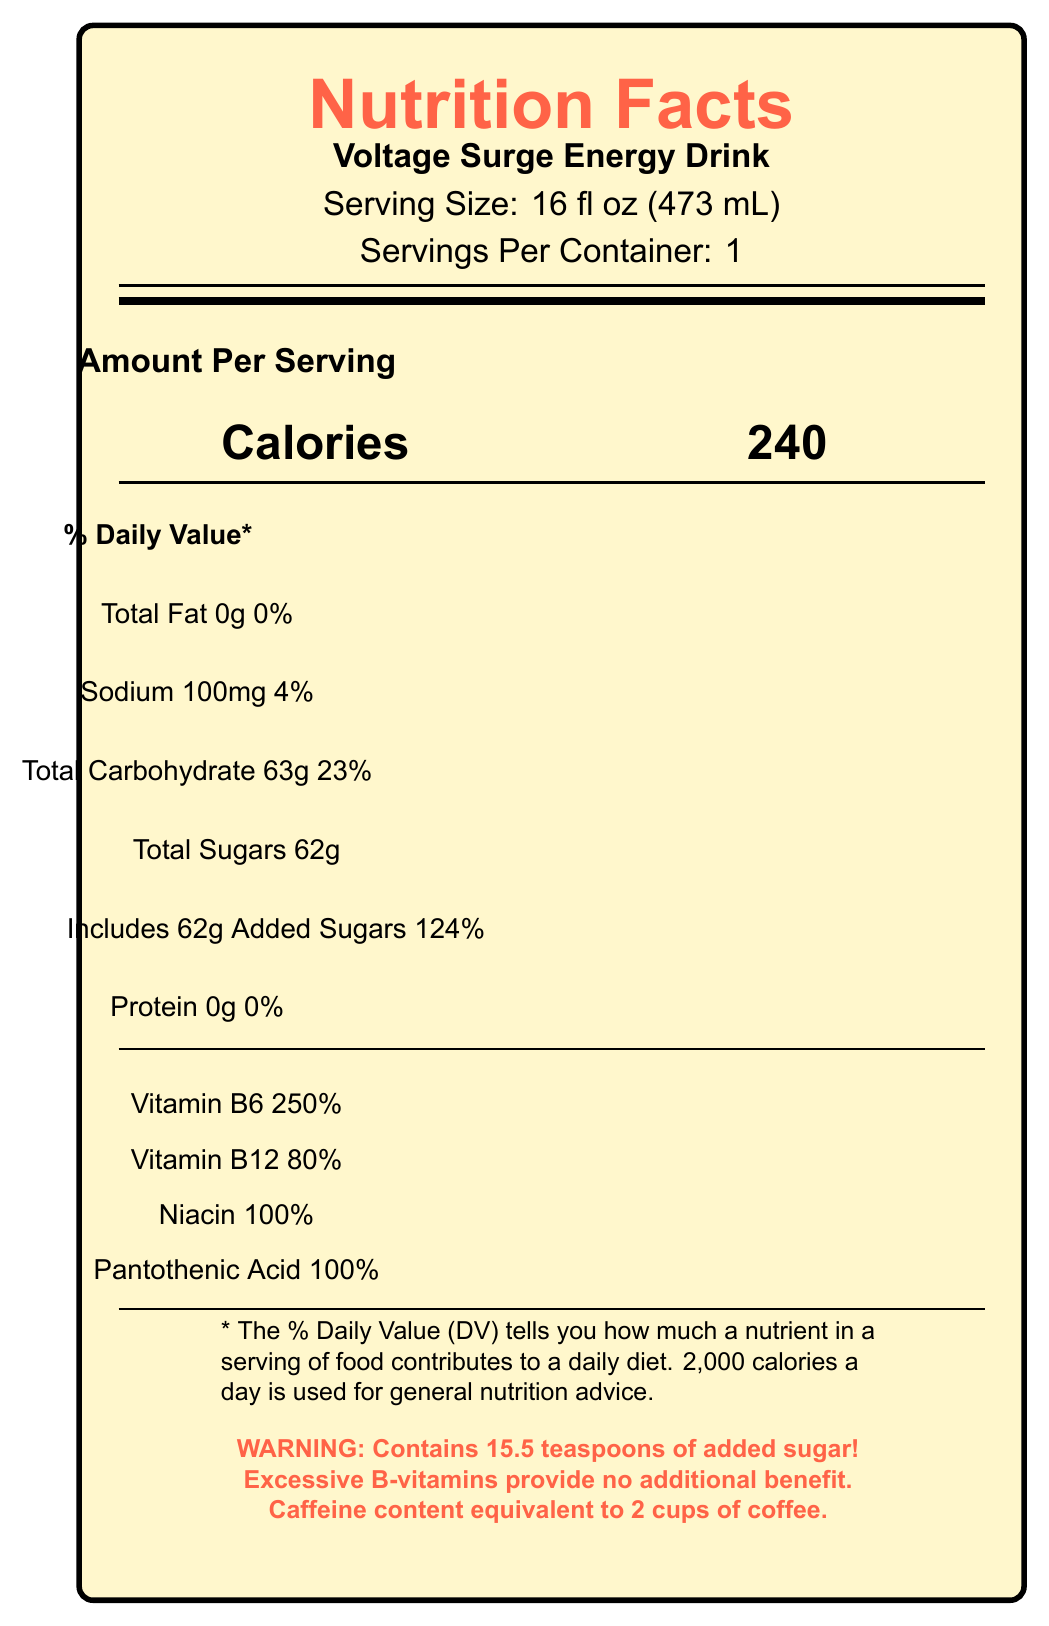what is the serving size of Voltage Surge Energy Drink? The Nutrition Facts label clearly states that the serving size is 16 fl oz (473 mL).
Answer: 16 fl oz (473 mL) how many calories are in one serving? The label shows that there are 240 calories per serving.
Answer: 240 how much sodium does this drink contain? According to the label, the drink contains 100mg of sodium.
Answer: 100mg how many total grams of sugar does this drink have? The label indicates that the drink contains 62 grams of total sugars.
Answer: 62g what is the percentage of daily value for added sugars? The label states that added sugars make up 124% of the daily value.
Answer: 124% what vitamins are included and what are their daily values? A. Vitamin C, 150% DV B. Vitamin D, 50% DV C. Vitamin B6, 250% DV D. Vitamin E, 75% DV The label shows vitamins and % daily values: Vitamin B6 is 250%, making option C the correct answer.
Answer: C how much caffeine does this drink contain? A. 100mg B. 120mg C. 160mg D. 200mg The label shows that the drink contains 160mg of caffeine.
Answer: C does this drink contain protein? The label clearly states that there is 0g of protein in the drink.
Answer: No does this drink contain any dietary fiber? The label does not mention any dietary fiber content.
Answer: No what ingredients are used in this drink? The label lists all these ingredients under the ingredients section.
Answer: Carbonated Water, Sugar, Citric Acid, Natural and Artificial Flavors, Sodium Citrate, Caffeine, Sodium Benzoate (Preservative), Potassium Sorbate (Preservative), Gum Arabic, Niacinamide (Vitamin B3), Calcium Pantothenate (Vitamin B5), Sucralose, Pyridoxine Hydrochloride (Vitamin B6), Cyanocobalamin (Vitamin B12), FD&C Blue #1, FD&C Red #40 how does the sugar content of this drink compare to the American Heart Association's daily recommended limit? The critic notes mention that the drink contains more sugar than the American Heart Association's daily recommended limit.
Answer: Exceeds the limit does B-vitamin content provide significant health benefits? The critic notes indicate that excessive B-vitamin content provides no additional benefit and is merely excreted.
Answer: No summarize the main nutritional characteristics of the Voltage Surge Energy Drink. The drink contains 62g of sugar (124% DV for added sugars), high amounts of B-vitamins, significant caffeine content (160mg), and no protein. The drink provides minimal nutritional value beyond excessive B-vitamins.
Answer: High sugar content, high in B-vitamins, high caffeine and zero protein. how much taurine is included in the drink? The label shows that the drink contains 1000mg of taurine.
Answer: 1000mg why is the excessive B-vitamin content seen as negative in the critic notes? The critic notes state that the excessive B-vitamin content provides no additional benefit and is merely excreted.
Answer: Provides no additional benefit and is merely excreted what is the amount of niacin in this drink expressed as a percentage of daily value? The label indicates that the niacin content is 100% of the daily value.
Answer: 100% what is the amount of calories from sugars alone? Each gram of sugar equals 4 calories. With 62 grams of sugar: 62g * 4 = 248 calories.
Answer: 248 calories is there any scientific evidence provided to support the performance-enhancing claims of the drink? The critic notes state that the drink is marketed as 'performance-enhancing' without scientific evidence.
Answer: No how many servings are there in one container? The label clearly states that there is 1 serving per container.
Answer: 1 how much pantothenic acid is present in the drink as a percentage of daily value? The label shows 100% daily value for pantothenic acid.
Answer: 100% what does the term 'energy blend' refer to in the context of this drink? `Energy blend` typically refers to the combination of these energizing ingredients listed on the label.
Answer: Caffeine, taurine, inositol, guarana extract, ginseng extract what is the main criticism regarding the use of artificial and natural flavors in the drink? The critic notes indicate that the terms 'natural and artificial flavors' are used to mask the actual ingredients.
Answer: Masks ingredients what are the preservatives used in this drink? The label lists sodium benzoate and potassium sorbate as the preservatives used.
Answer: Sodium benzoate and potassium sorbate 